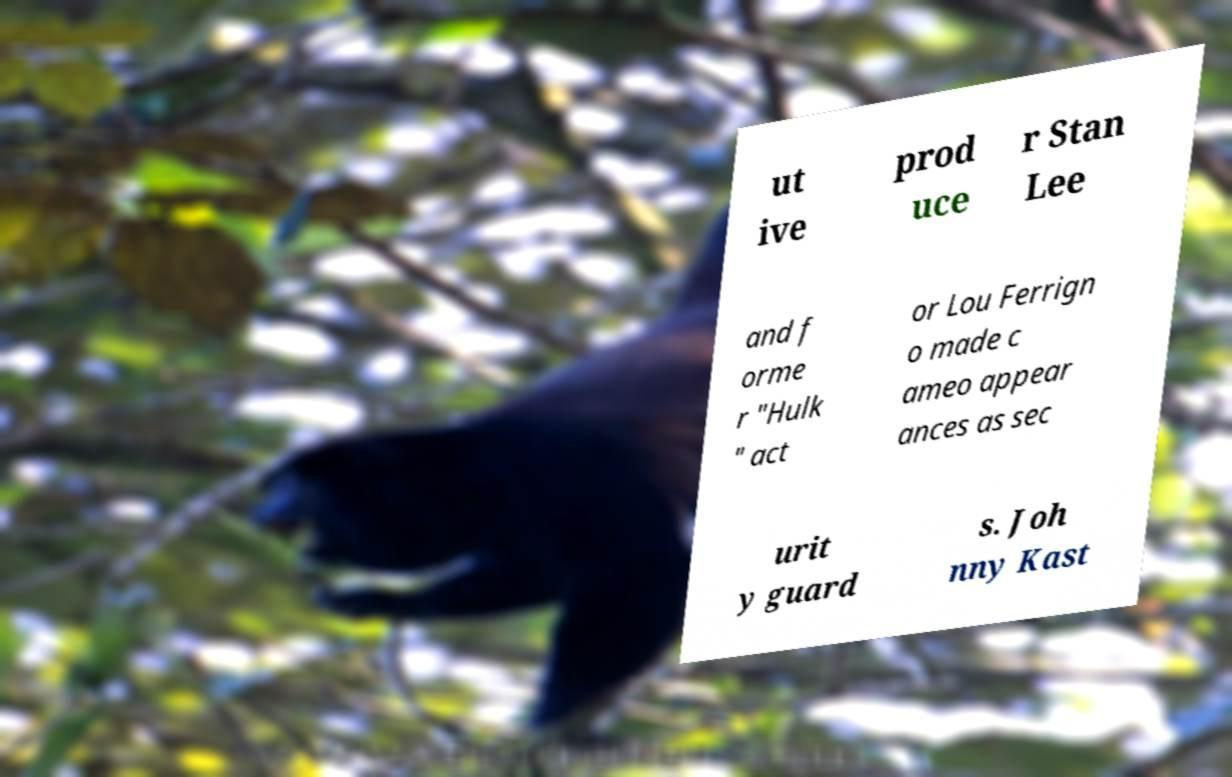There's text embedded in this image that I need extracted. Can you transcribe it verbatim? ut ive prod uce r Stan Lee and f orme r "Hulk " act or Lou Ferrign o made c ameo appear ances as sec urit y guard s. Joh nny Kast 